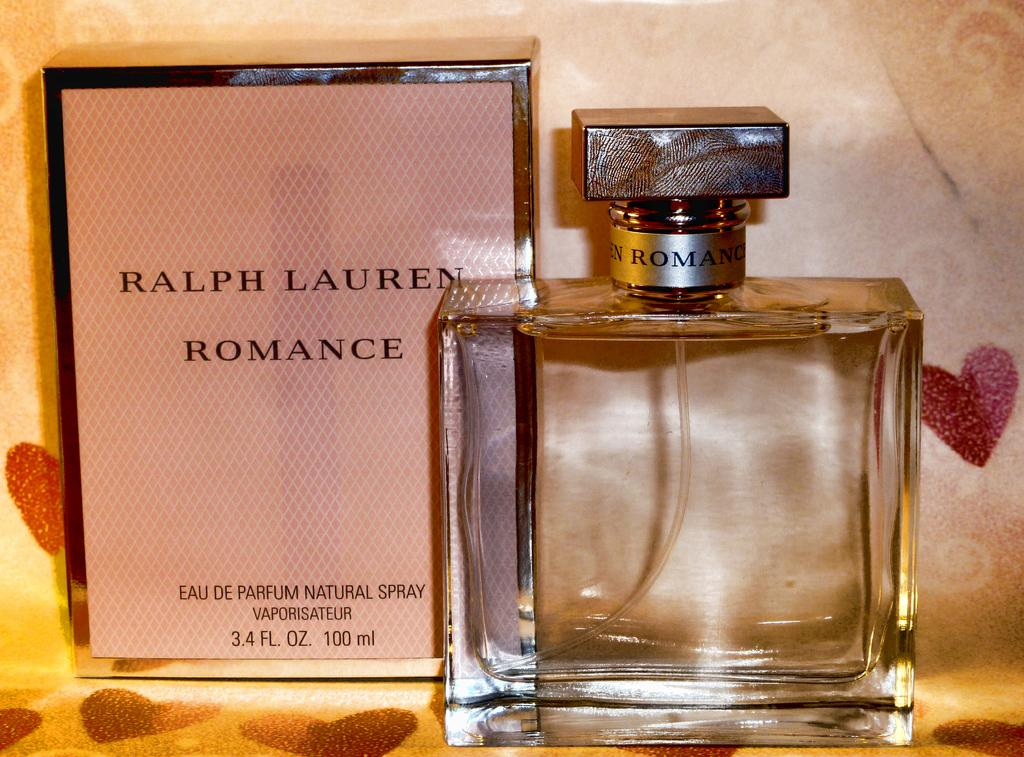<image>
Describe the image concisely. A box of Ralph Lauren Romance brand perfume beside the bottle 